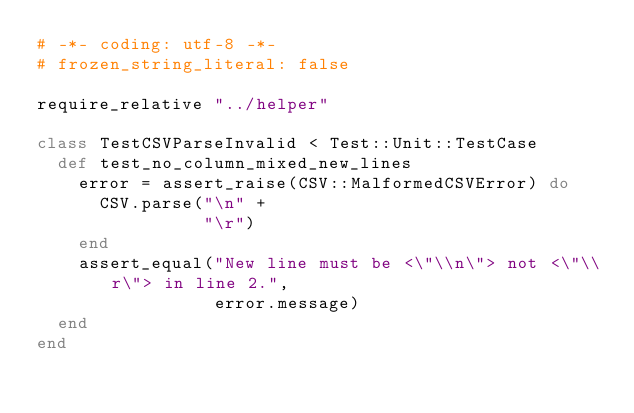Convert code to text. <code><loc_0><loc_0><loc_500><loc_500><_Ruby_># -*- coding: utf-8 -*-
# frozen_string_literal: false

require_relative "../helper"

class TestCSVParseInvalid < Test::Unit::TestCase
  def test_no_column_mixed_new_lines
    error = assert_raise(CSV::MalformedCSVError) do
      CSV.parse("\n" +
                "\r")
    end
    assert_equal("New line must be <\"\\n\"> not <\"\\r\"> in line 2.",
                 error.message)
  end
end
</code> 